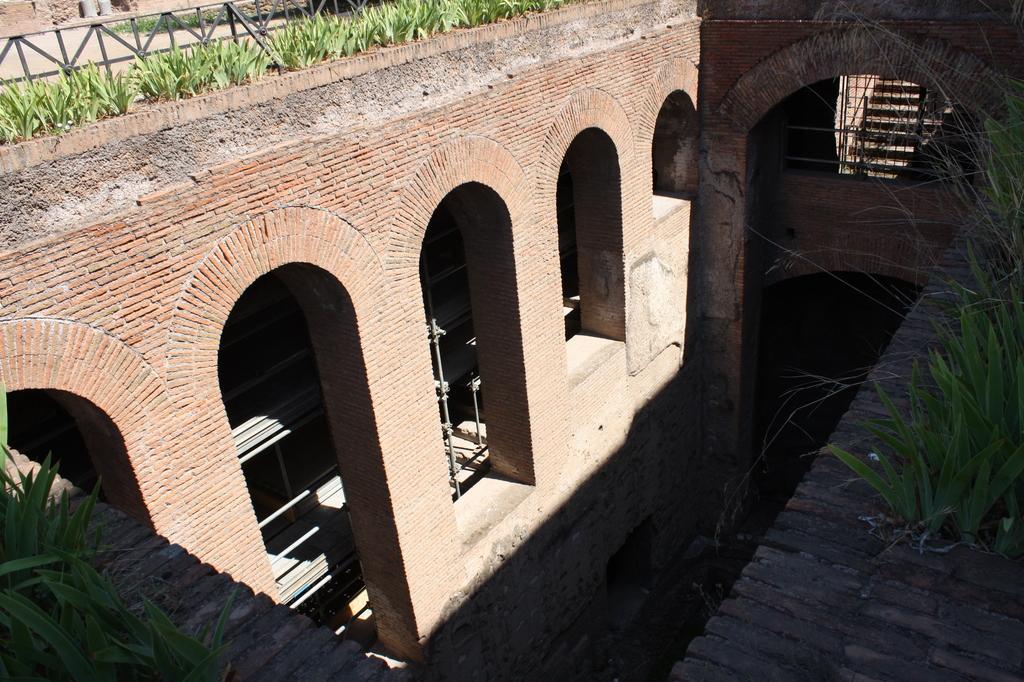Describe this image in one or two sentences. In this picture we can see buildings, rods, steps, fence, plants. 